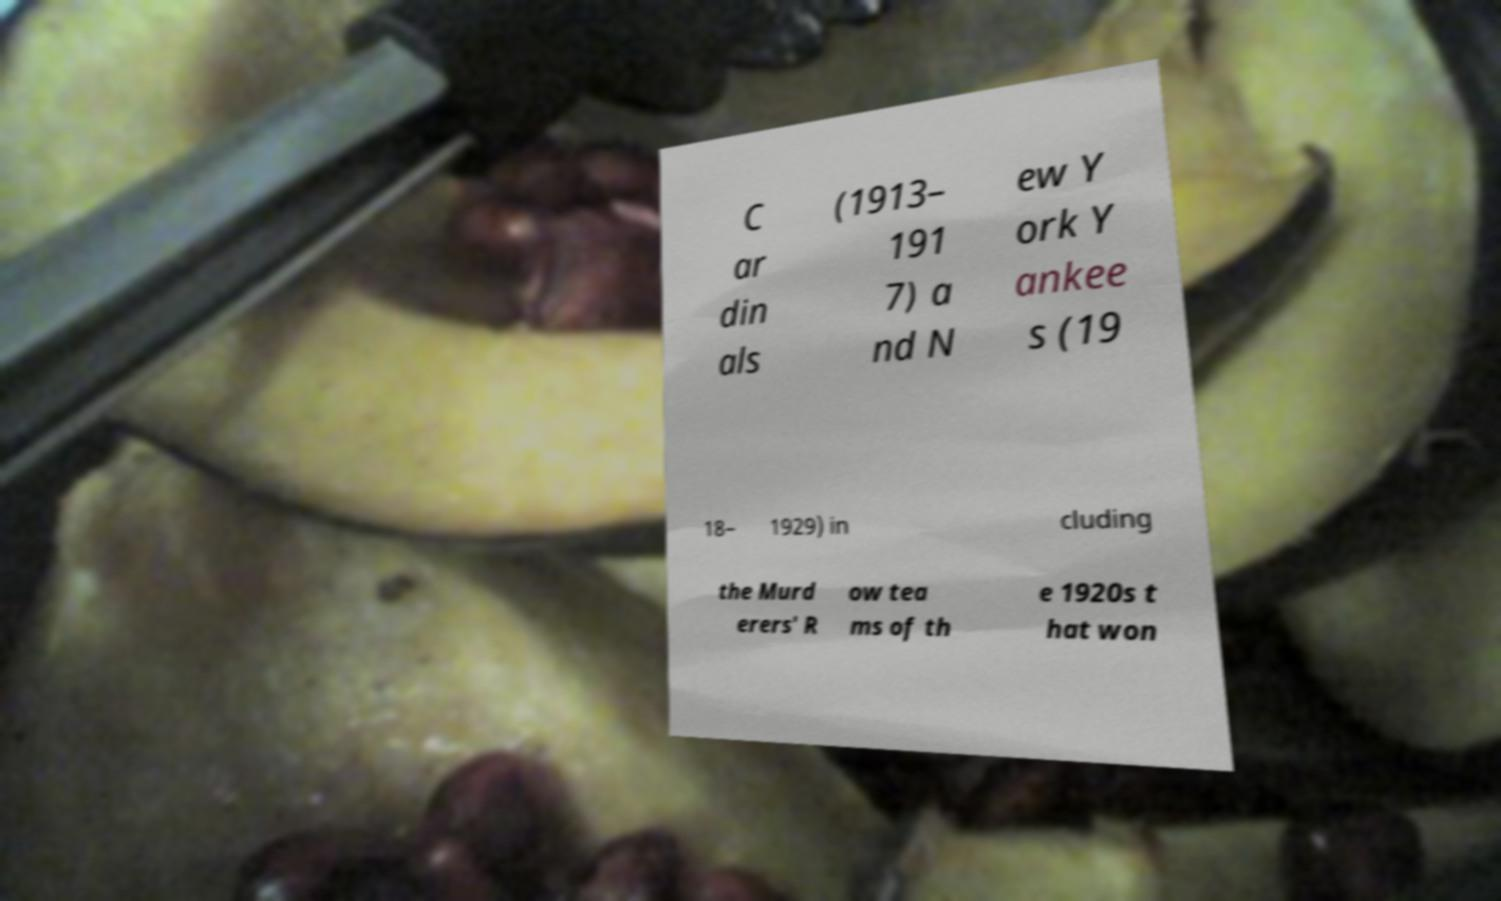For documentation purposes, I need the text within this image transcribed. Could you provide that? C ar din als (1913– 191 7) a nd N ew Y ork Y ankee s (19 18– 1929) in cluding the Murd erers' R ow tea ms of th e 1920s t hat won 